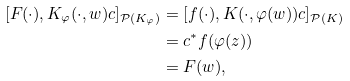<formula> <loc_0><loc_0><loc_500><loc_500>[ F ( \cdot ) , K _ { \varphi } ( \cdot , w ) c ] _ { \mathcal { P } ( K _ { \varphi } ) } & = [ f ( \cdot ) , K ( \cdot , \varphi ( w ) ) c ] _ { \mathcal { P } ( K ) } \\ & = c ^ { * } f ( \varphi ( z ) ) \\ & = F ( w ) ,</formula> 